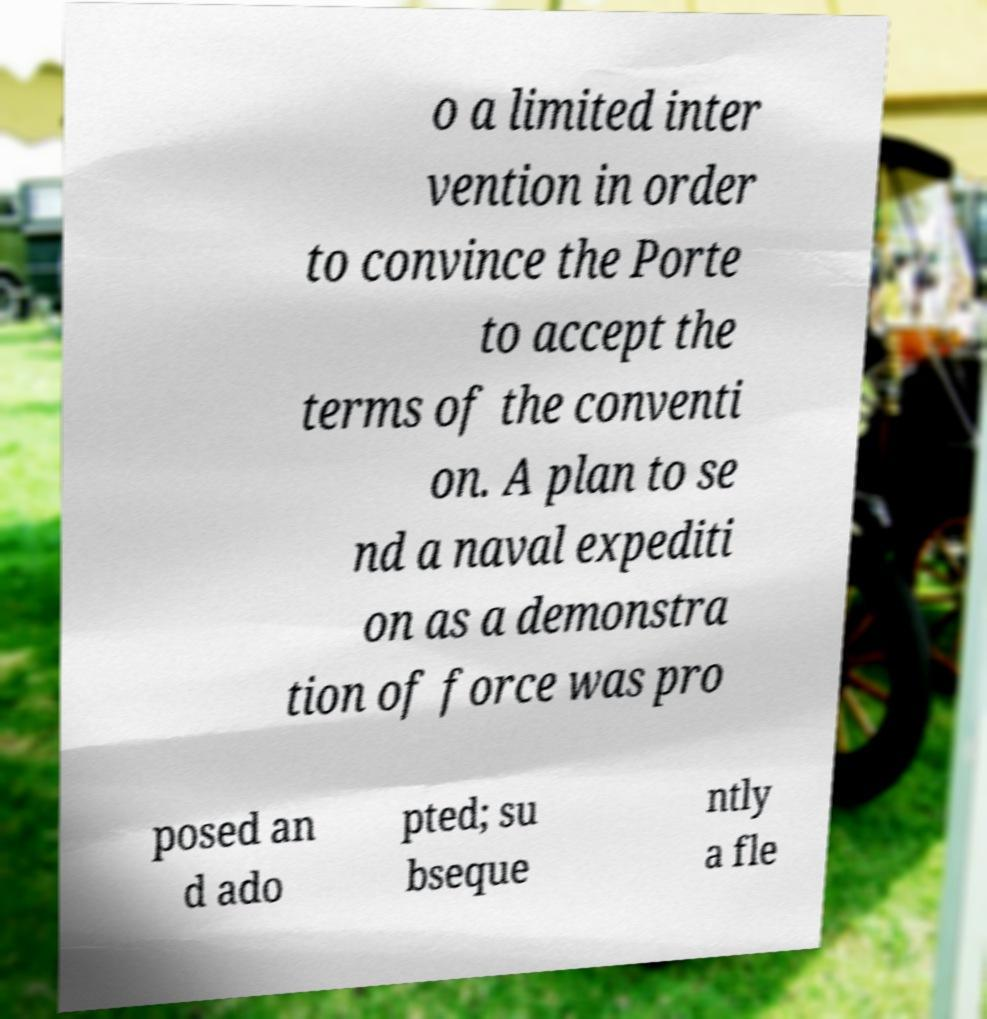For documentation purposes, I need the text within this image transcribed. Could you provide that? o a limited inter vention in order to convince the Porte to accept the terms of the conventi on. A plan to se nd a naval expediti on as a demonstra tion of force was pro posed an d ado pted; su bseque ntly a fle 